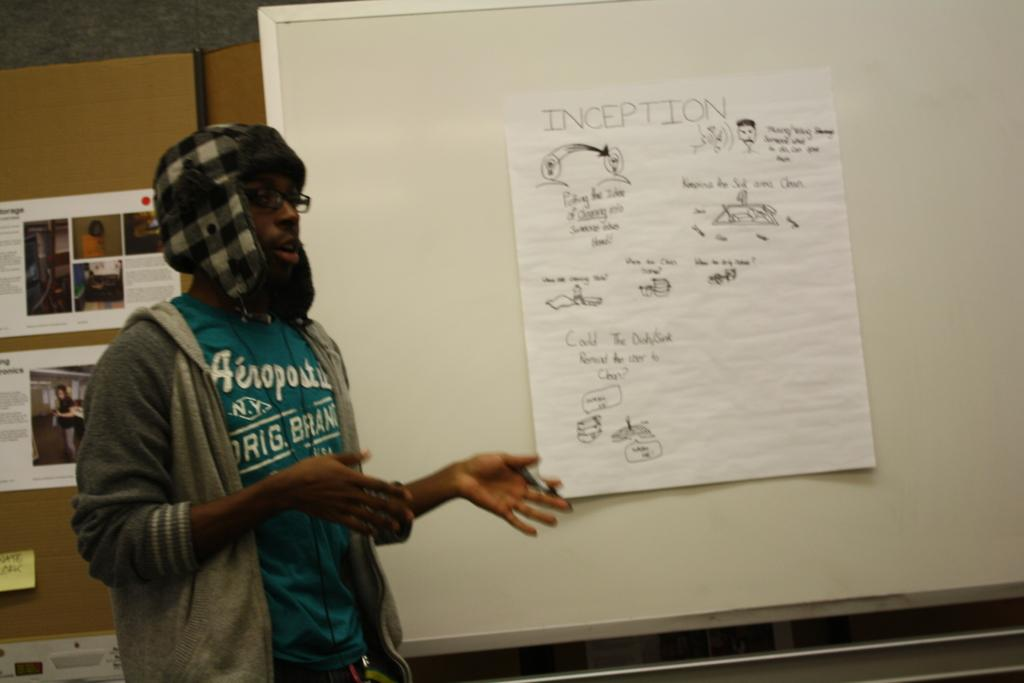Provide a one-sentence caption for the provided image. A man stands in front of a whiteboard pointing to a page titled Inception. 